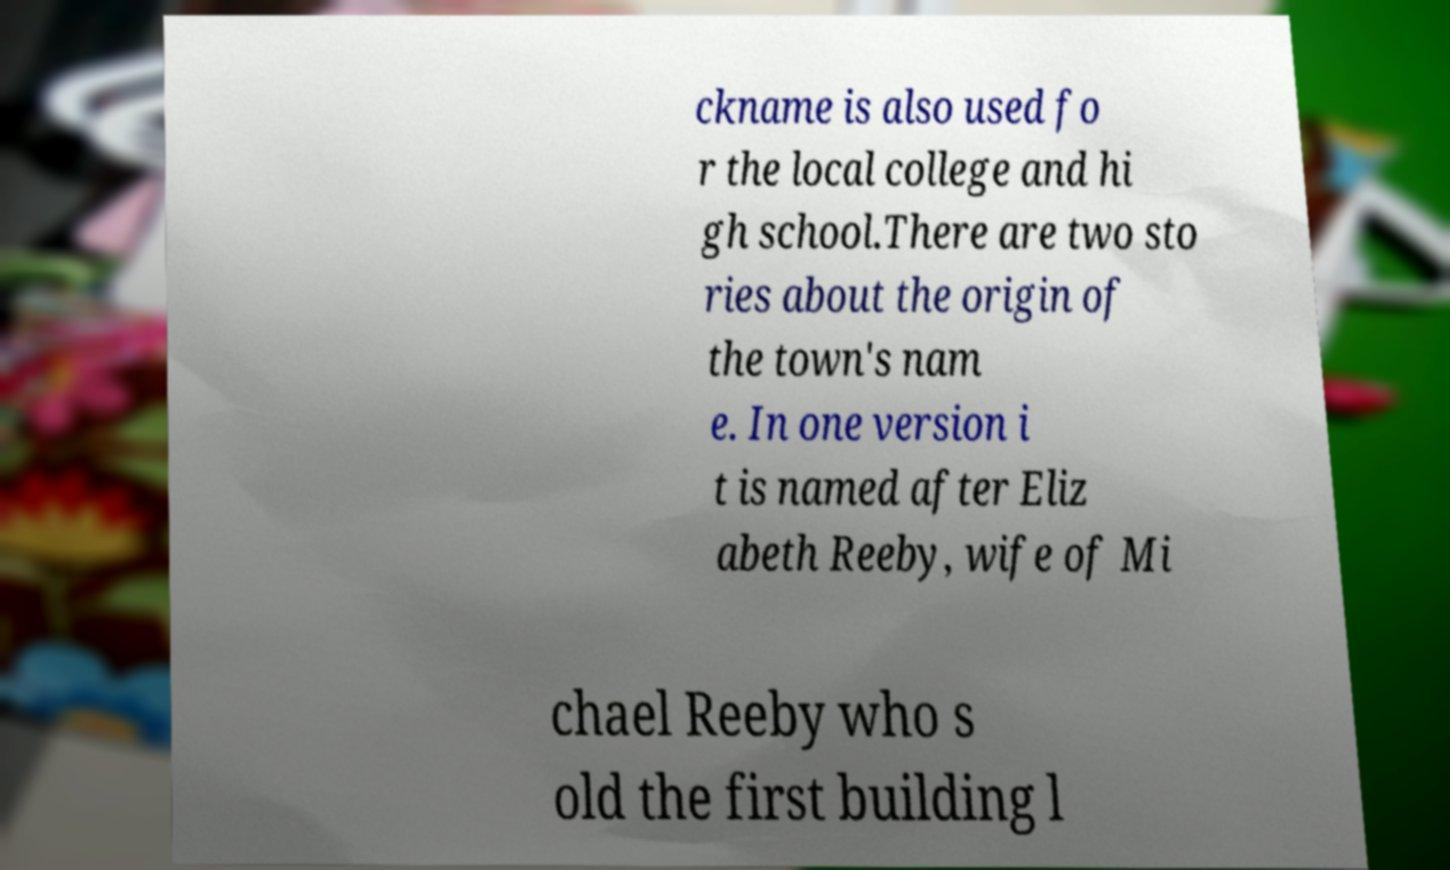I need the written content from this picture converted into text. Can you do that? ckname is also used fo r the local college and hi gh school.There are two sto ries about the origin of the town's nam e. In one version i t is named after Eliz abeth Reeby, wife of Mi chael Reeby who s old the first building l 